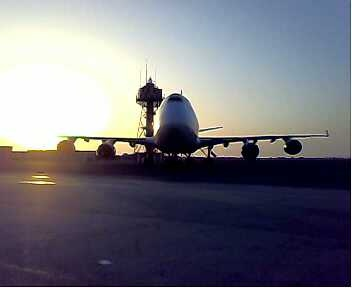Describe the objects in this image and their specific colors. I can see a airplane in lightgray, black, gray, beige, and darkgray tones in this image. 